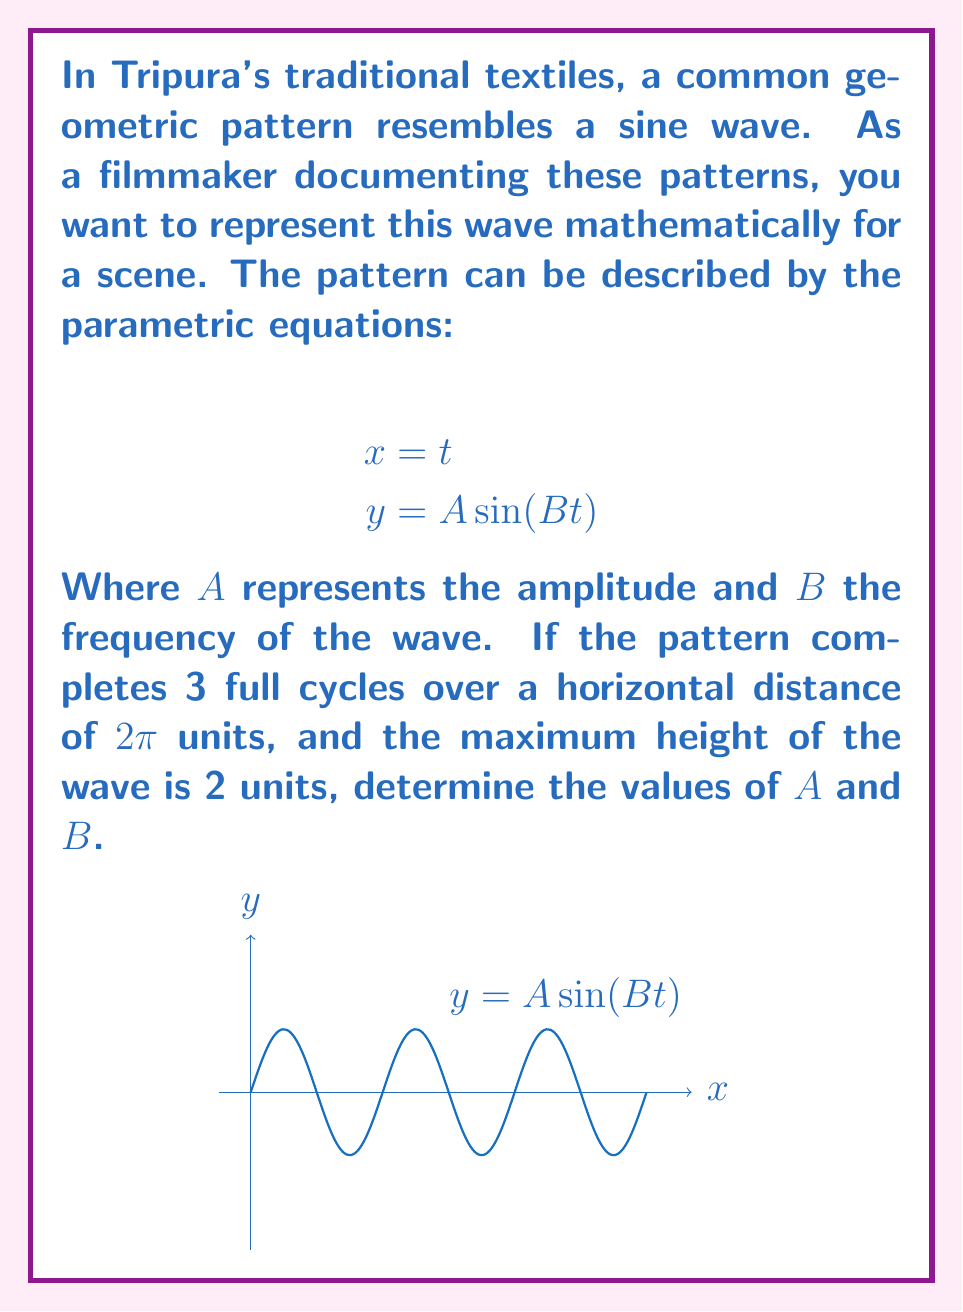Could you help me with this problem? Let's approach this step-by-step:

1) First, let's consider the amplitude $A$. The maximum height of the wave is given as 2 units. In a sine function, the amplitude is half of the total height (from trough to crest). Therefore:

   $A = 2 \div 2 = 1$

2) Now, for the frequency $B$, we need to consider the number of cycles completed over the given horizontal distance.

3) In general, one full cycle of a sine wave occurs over a distance of $2\pi$ units when $B=1$. 

4) We're told that 3 full cycles occur over a distance of $2\pi$ units. This means the frequency is 3 times what it would be for a single cycle. Therefore:

   $B = 3$

5) We can verify this: In the equation $y = A \sin(Bt)$, when $t$ goes from 0 to $2\pi$, $Bt$ goes from 0 to $6\pi$, which indeed represents 3 full cycles.

6) Therefore, the complete parametric equations are:

   $$x = t$$
   $$y = \sin(3t)$$
Answer: $A = 1, B = 3$ 